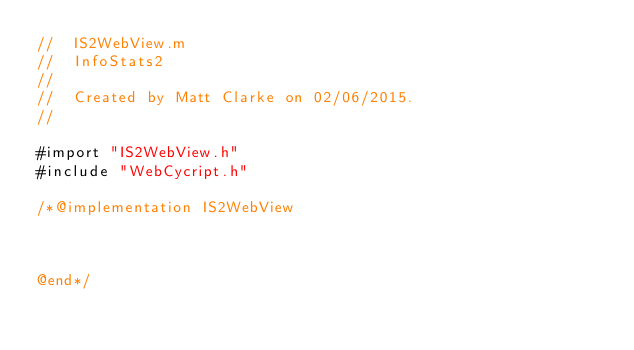<code> <loc_0><loc_0><loc_500><loc_500><_ObjectiveC_>//  IS2WebView.m
//  InfoStats2
//
//  Created by Matt Clarke on 02/06/2015.
//

#import "IS2WebView.h"
#include "WebCycript.h"

/*@implementation IS2WebView



@end*/
</code> 